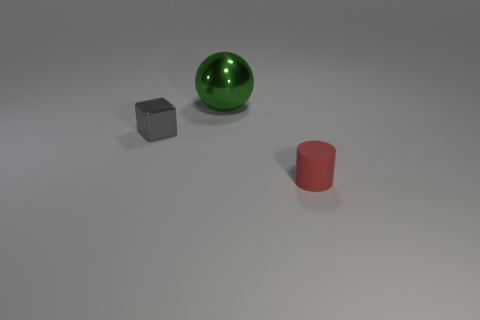Add 2 big metal things. How many objects exist? 5 Subtract all cylinders. How many objects are left? 2 Add 3 small cylinders. How many small cylinders are left? 4 Add 1 tiny matte cylinders. How many tiny matte cylinders exist? 2 Subtract 1 gray cubes. How many objects are left? 2 Subtract all tiny cyan rubber things. Subtract all green spheres. How many objects are left? 2 